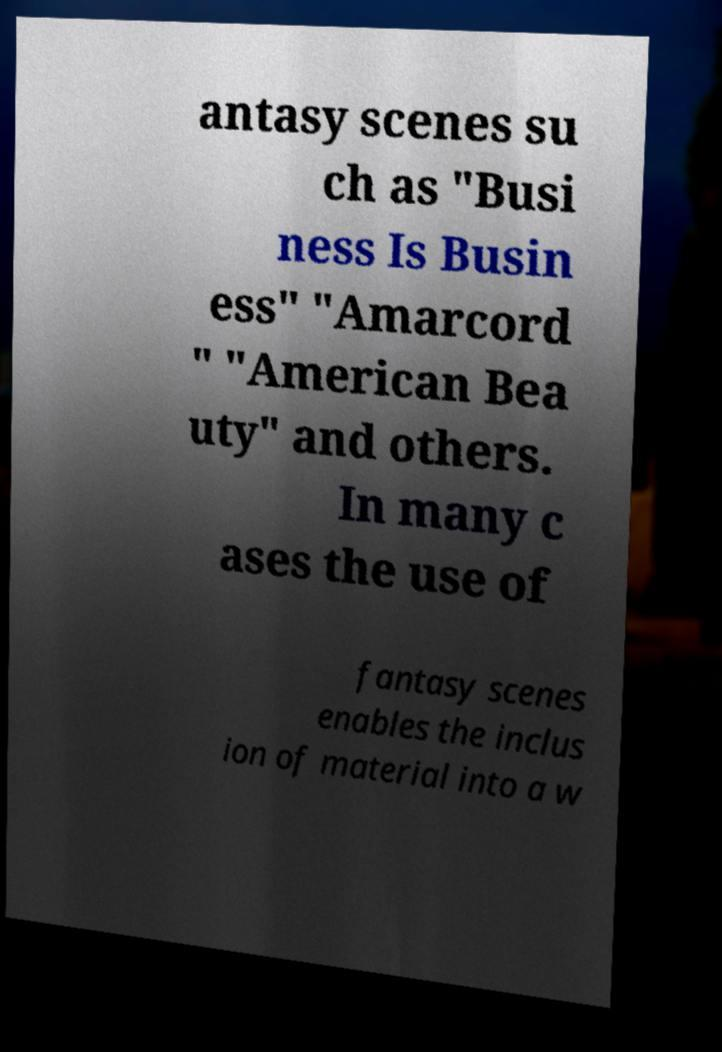Can you accurately transcribe the text from the provided image for me? antasy scenes su ch as "Busi ness Is Busin ess" "Amarcord " "American Bea uty" and others. In many c ases the use of fantasy scenes enables the inclus ion of material into a w 